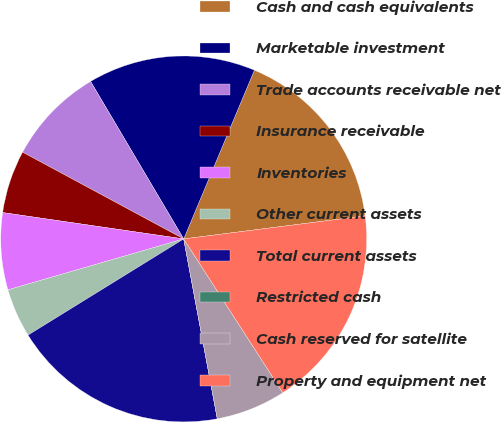Convert chart. <chart><loc_0><loc_0><loc_500><loc_500><pie_chart><fcel>Cash and cash equivalents<fcel>Marketable investment<fcel>Trade accounts receivable net<fcel>Insurance receivable<fcel>Inventories<fcel>Other current assets<fcel>Total current assets<fcel>Restricted cash<fcel>Cash reserved for satellite<fcel>Property and equipment net<nl><fcel>16.67%<fcel>14.81%<fcel>8.64%<fcel>5.56%<fcel>6.79%<fcel>4.32%<fcel>19.13%<fcel>0.0%<fcel>6.17%<fcel>17.9%<nl></chart> 